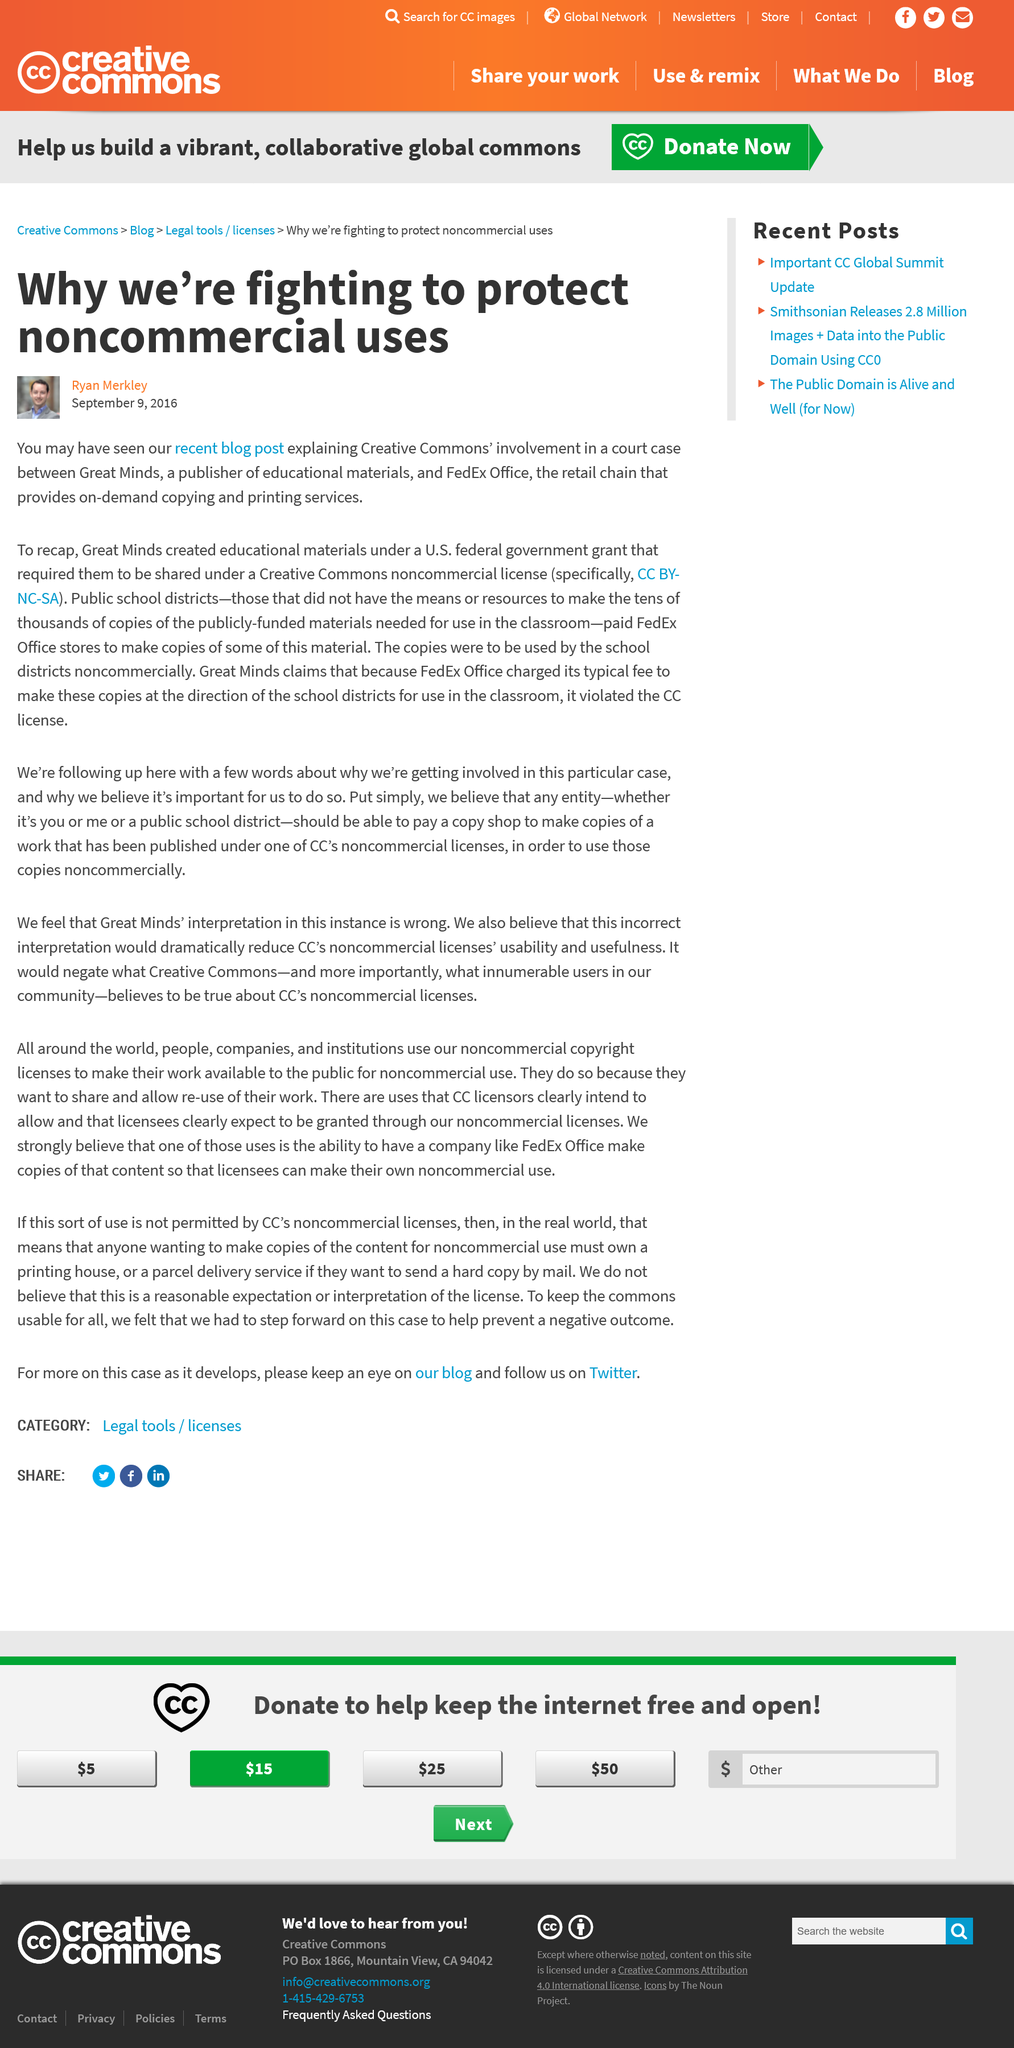Draw attention to some important aspects in this diagram. FedEx is mentioned in the retain chain as a company that retains a marketing agency. Great Minds is a publisher that produces educational material for various educational purposes. The copies were to be used by the school districts noncommercially. 